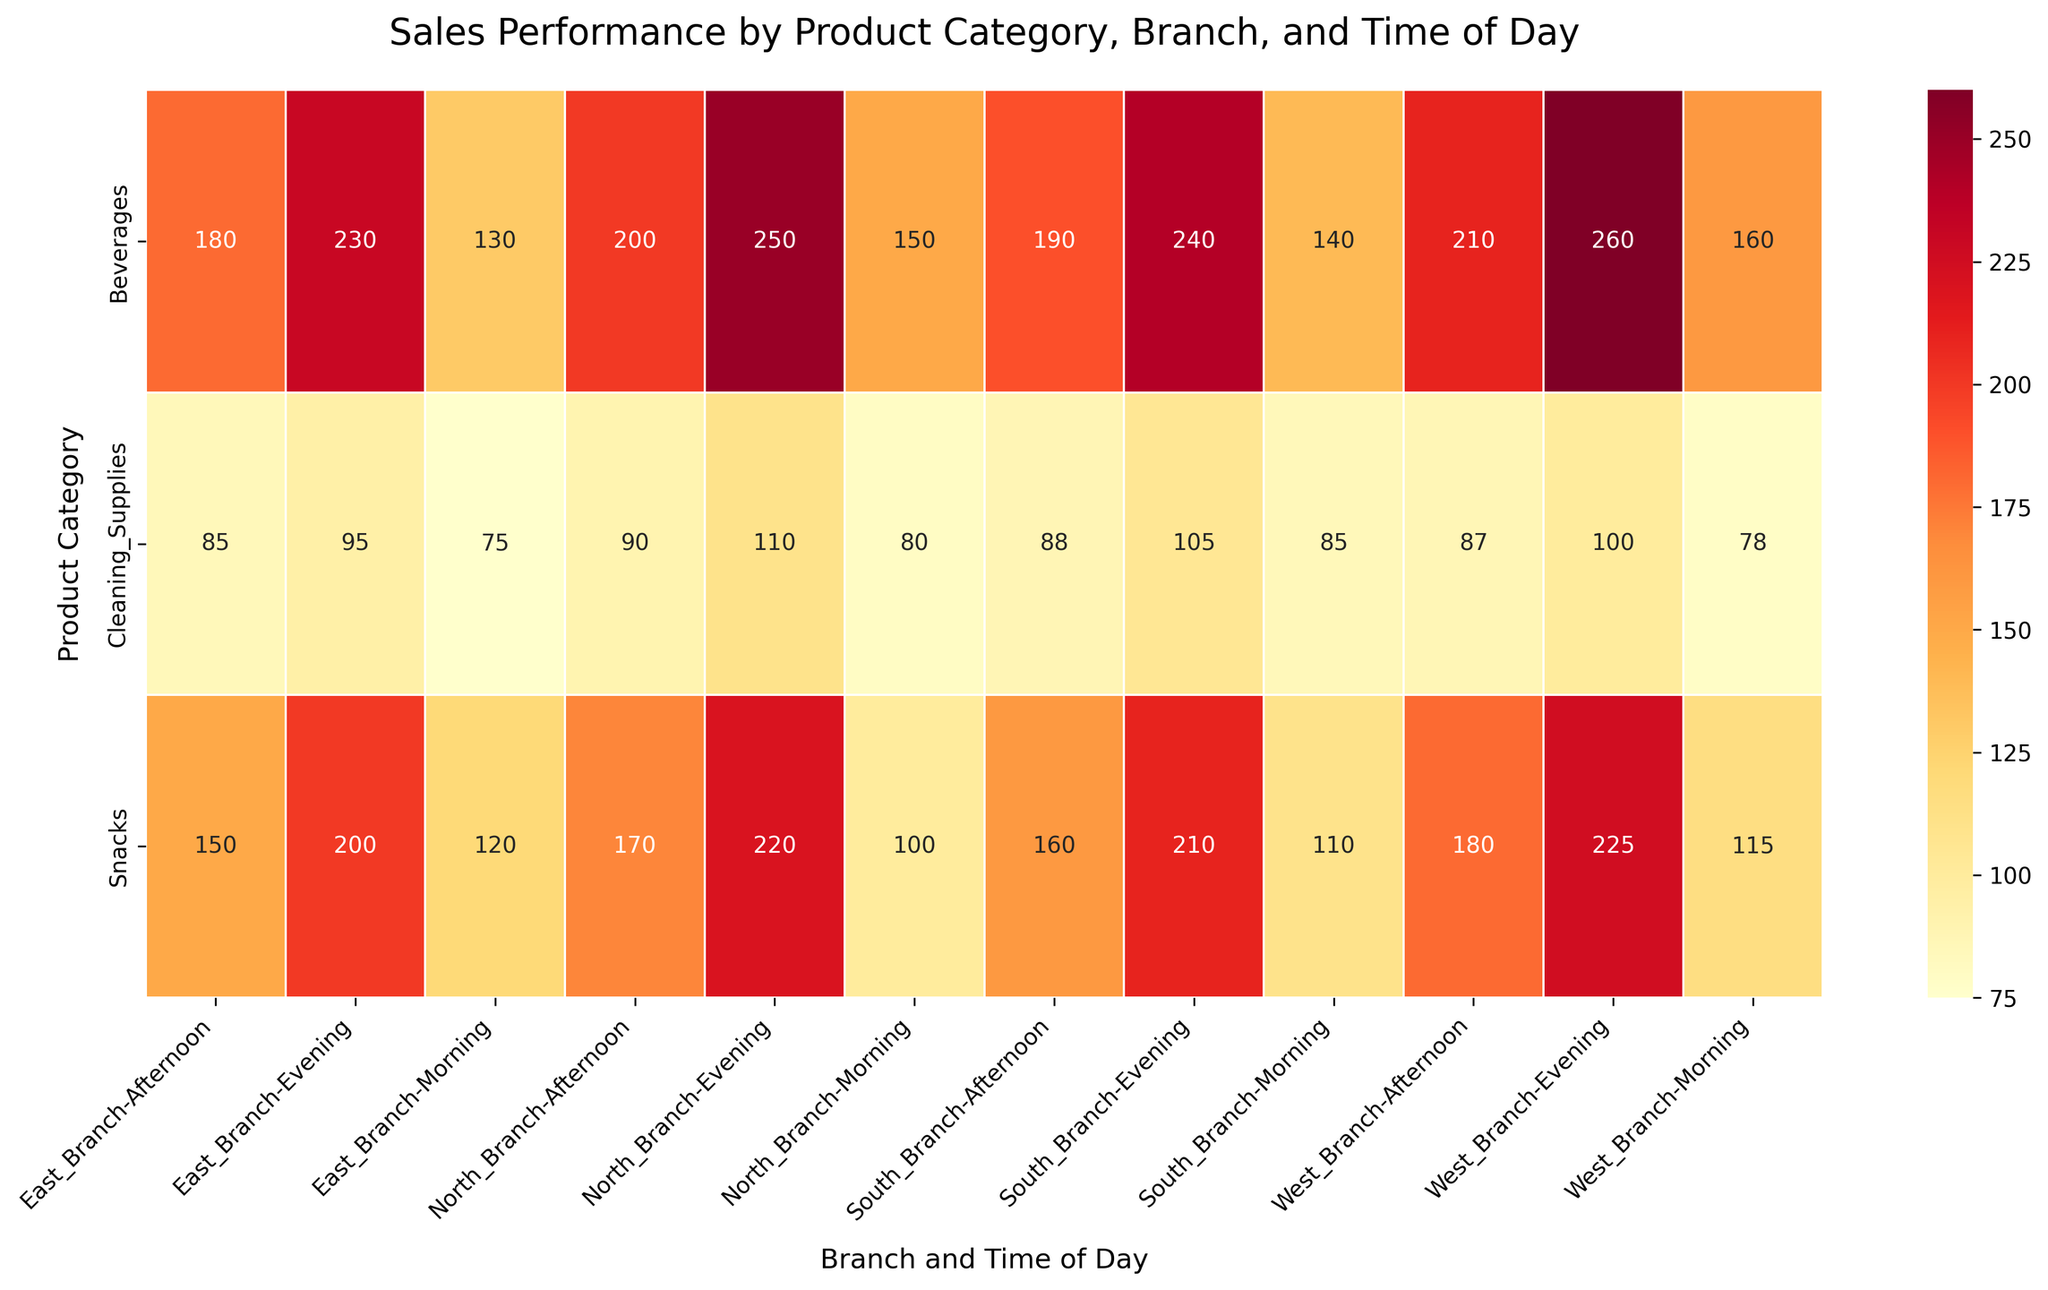What is the title of the heatmap? The title of the heatmap is displayed at the top center of the figure. It gives a summary of what the figure represents.
Answer: Sales Performance by Product Category, Branch, and Time of Day Which product category has the highest sales in the North Branch during the evening? Look at the North Branch column, focus on the cells marked for Evening, and identify the product category with the highest sales value.
Answer: Beverages How do morning sales of cleaning supplies compare across all branches? Check the cells corresponding to Cleaning Supplies in the rows for Morning and compare the sales values across different branch columns (North, South, East, West).
Answer: West Branch has the highest, followed by South, North, and East What is the total sales for snacks in the Afternoon across all branches? Find sales values for Snacks in the Afternoon for each branch (North, South, East, West). Sum these values: 170 (North) + 160 (South) + 150 (East) + 180 (West).
Answer: 660 Which time of day generates more revenue for beverages in the West Branch: Morning or Afternoon? Compare the sales values for beverages in the Morning and Afternoon in the West Branch column.
Answer: Afternoon What is the average sales value for beverages in the South Branch? Add the sales values for beverages in the Morning, Afternoon, and Evening in the South Branch column and divide by 3 to get the average. (140 + 190 + 240)/3
Answer: 190 Do cleaning supplies generally perform better in the Evening compared to the Morning across branches? Compare the Evening sales values for Cleaning Supplies across all branches with the corresponding Morning values. Summarize if Evening has consistently higher sales.
Answer: Yes Which branch has the least sales for snacks in the Morning? Look at the sales values for Snacks in the Morning across all branch columns and identify the smallest number.
Answer: North Branch How does sales performance of beverages change from Morning to Evening in the East Branch? Compare the sales values for beverages in the Morning and Evening in the East Branch column.
Answer: Increases from 130 to 230 Is there any time-of-day trend noticeable for the snack sales across all branches? Observe the sales values for Snacks in Morning, Afternoon, and Evening across all branches to identify any upward or downward trends.
Answer: Increases from Morning to Evening 